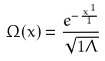<formula> <loc_0><loc_0><loc_500><loc_500>\Omega ( x ) = \frac { e ^ { - \frac { x ^ { 1 } } { 1 } } } { \sqrt { 1 \Lambda } }</formula> 